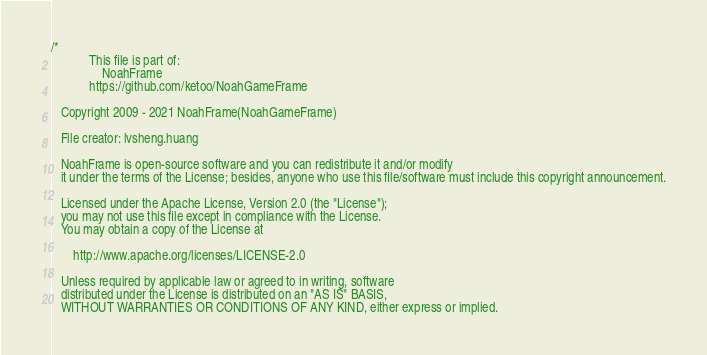Convert code to text. <code><loc_0><loc_0><loc_500><loc_500><_C++_>/*
            This file is part of: 
                NoahFrame
            https://github.com/ketoo/NoahGameFrame

   Copyright 2009 - 2021 NoahFrame(NoahGameFrame)

   File creator: lvsheng.huang
   
   NoahFrame is open-source software and you can redistribute it and/or modify
   it under the terms of the License; besides, anyone who use this file/software must include this copyright announcement.

   Licensed under the Apache License, Version 2.0 (the "License");
   you may not use this file except in compliance with the License.
   You may obtain a copy of the License at

       http://www.apache.org/licenses/LICENSE-2.0

   Unless required by applicable law or agreed to in writing, software
   distributed under the License is distributed on an "AS IS" BASIS,
   WITHOUT WARRANTIES OR CONDITIONS OF ANY KIND, either express or implied.</code> 